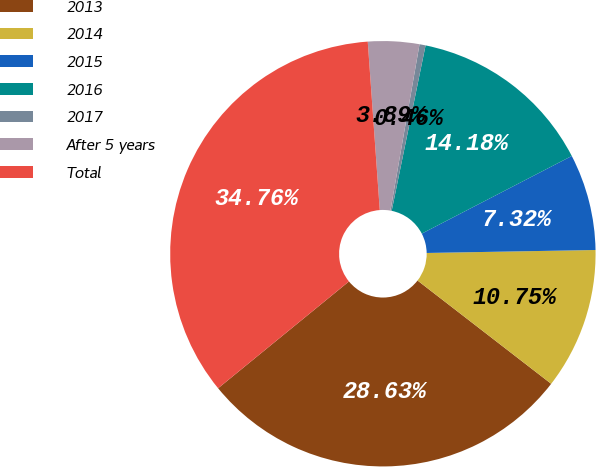<chart> <loc_0><loc_0><loc_500><loc_500><pie_chart><fcel>2013<fcel>2014<fcel>2015<fcel>2016<fcel>2017<fcel>After 5 years<fcel>Total<nl><fcel>28.63%<fcel>10.75%<fcel>7.32%<fcel>14.18%<fcel>0.46%<fcel>3.89%<fcel>34.76%<nl></chart> 